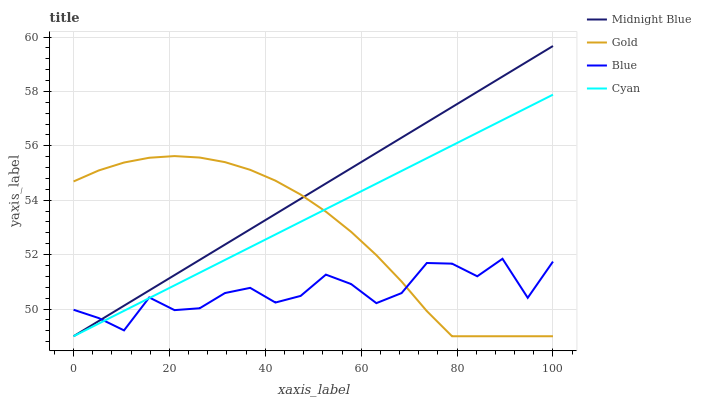Does Blue have the minimum area under the curve?
Answer yes or no. Yes. Does Midnight Blue have the maximum area under the curve?
Answer yes or no. Yes. Does Cyan have the minimum area under the curve?
Answer yes or no. No. Does Cyan have the maximum area under the curve?
Answer yes or no. No. Is Cyan the smoothest?
Answer yes or no. Yes. Is Blue the roughest?
Answer yes or no. Yes. Is Midnight Blue the smoothest?
Answer yes or no. No. Is Midnight Blue the roughest?
Answer yes or no. No. Does Cyan have the lowest value?
Answer yes or no. Yes. Does Midnight Blue have the highest value?
Answer yes or no. Yes. Does Cyan have the highest value?
Answer yes or no. No. Does Midnight Blue intersect Cyan?
Answer yes or no. Yes. Is Midnight Blue less than Cyan?
Answer yes or no. No. Is Midnight Blue greater than Cyan?
Answer yes or no. No. 